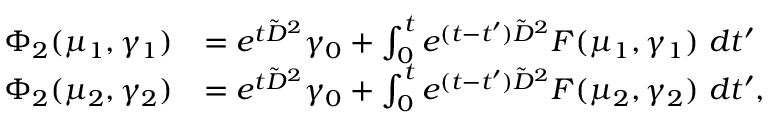<formula> <loc_0><loc_0><loc_500><loc_500>\begin{array} { r l } { \Phi _ { 2 } ( \mu _ { 1 } , \gamma _ { 1 } ) } & { = e ^ { t \tilde { D } ^ { 2 } } \gamma _ { 0 } + \int _ { 0 } ^ { t } e ^ { ( t - t ^ { \prime } ) \tilde { D } ^ { 2 } } F ( \mu _ { 1 } , \gamma _ { 1 } ) \ d t ^ { \prime } } \\ { \Phi _ { 2 } ( \mu _ { 2 } , \gamma _ { 2 } ) } & { = e ^ { t \tilde { D } ^ { 2 } } \gamma _ { 0 } + \int _ { 0 } ^ { t } e ^ { ( t - t ^ { \prime } ) \tilde { D } ^ { 2 } } F ( \mu _ { 2 } , \gamma _ { 2 } ) \ d t ^ { \prime } , } \end{array}</formula> 